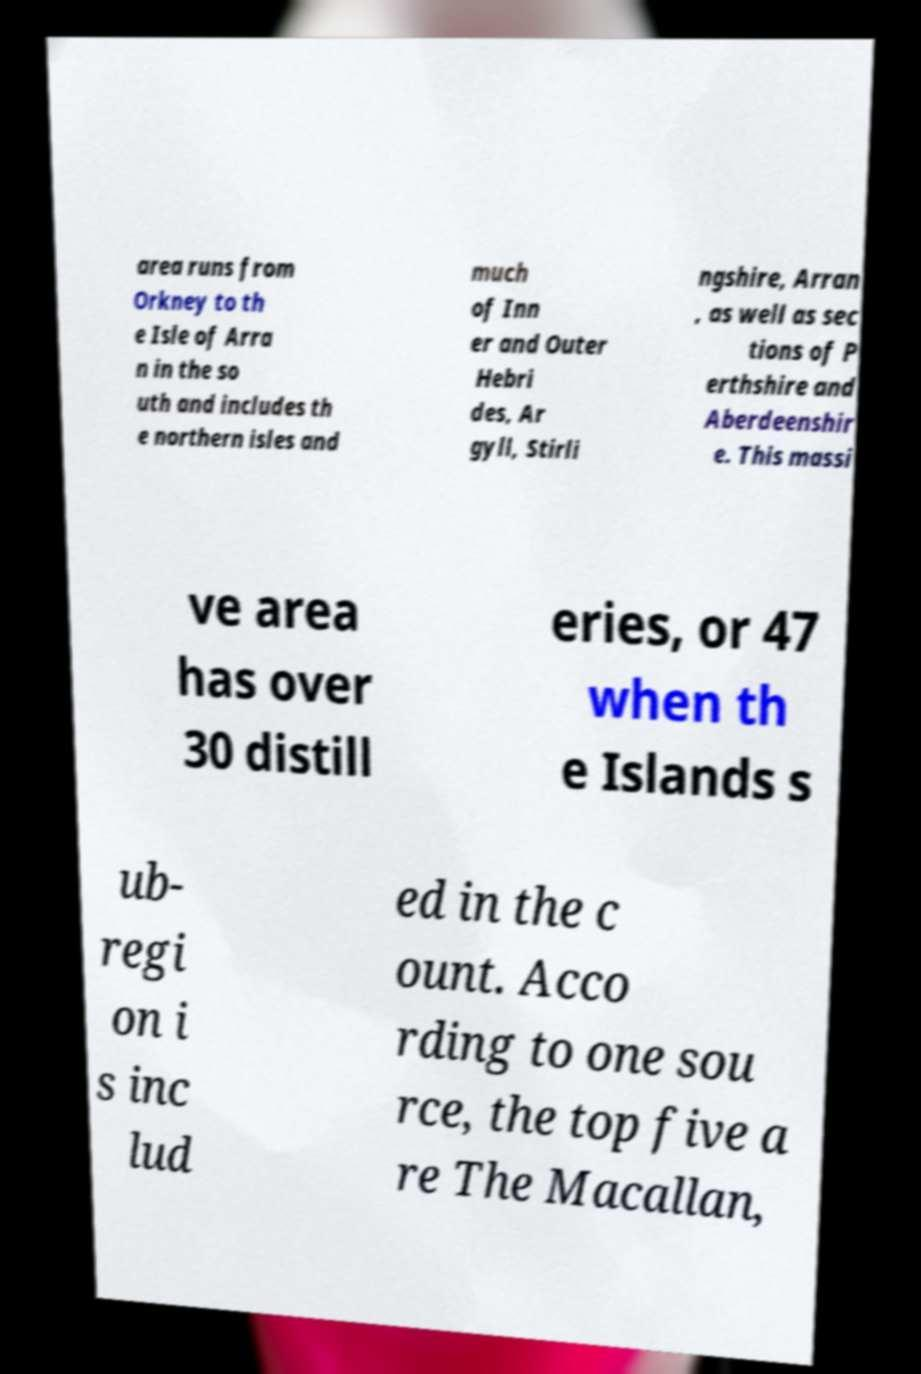For documentation purposes, I need the text within this image transcribed. Could you provide that? area runs from Orkney to th e Isle of Arra n in the so uth and includes th e northern isles and much of Inn er and Outer Hebri des, Ar gyll, Stirli ngshire, Arran , as well as sec tions of P erthshire and Aberdeenshir e. This massi ve area has over 30 distill eries, or 47 when th e Islands s ub- regi on i s inc lud ed in the c ount. Acco rding to one sou rce, the top five a re The Macallan, 